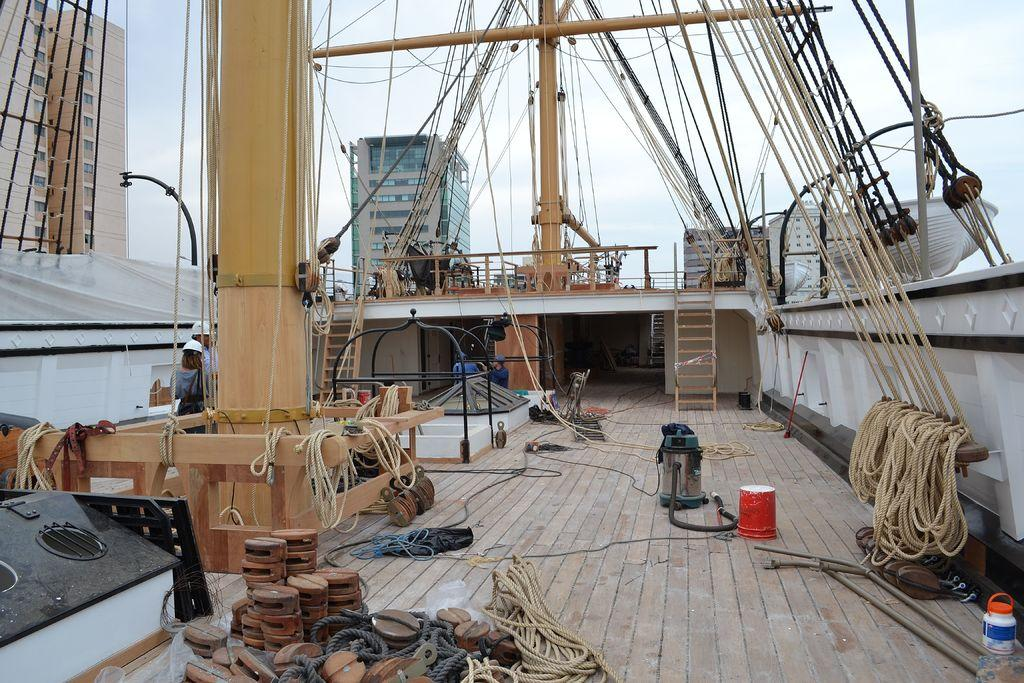What objects can be seen in the image that are used for tying or securing? There are ropes in the image that can be used for tying or securing. What objects can be seen in the image that are tall and vertical? There are poles in the image that are tall and vertical. What can be seen in the distance in the image? There are buildings in the background of the image. What type of paper is being used to support the ropes in the image? There is no paper present in the image, and the ropes are not being supported by any paper. 